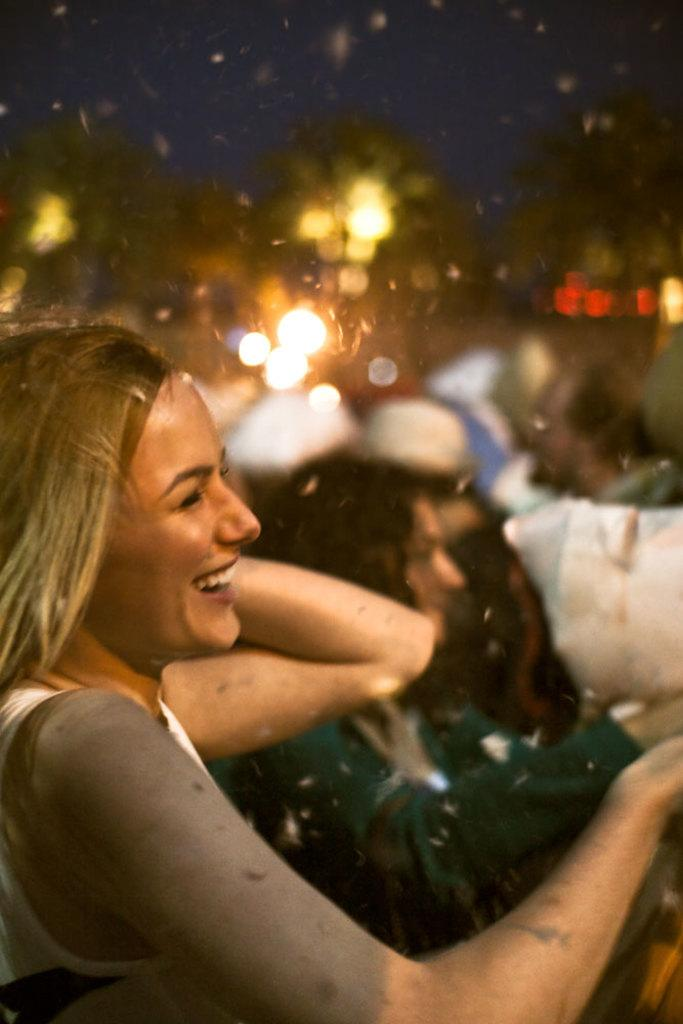What is the main subject of the image? There is a person in the image. Can you describe the background of the image? The background of the image is blurred. What type of knife can be seen in the aftermath of the rabbit's escape in the image? There is no knife, aftermath, or rabbit present in the image. 